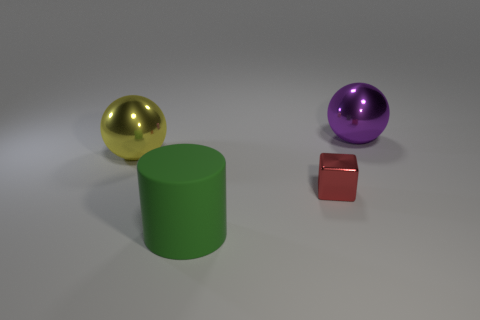Is there anything else that is the same material as the large green cylinder?
Your answer should be very brief. No. How many metallic things are both behind the shiny cube and right of the green cylinder?
Keep it short and to the point. 1. How many rubber things are yellow cylinders or big cylinders?
Keep it short and to the point. 1. The big thing behind the shiny sphere that is to the left of the large green matte thing is made of what material?
Ensure brevity in your answer.  Metal. There is a yellow object that is the same size as the purple thing; what is its shape?
Your response must be concise. Sphere. Is the number of large yellow objects less than the number of yellow matte balls?
Offer a very short reply. No. Are there any large shiny things that are left of the big metal object right of the metallic block?
Provide a short and direct response. Yes. What is the shape of the large purple object that is made of the same material as the yellow ball?
Make the answer very short. Sphere. Are there any other things of the same color as the big rubber thing?
Provide a short and direct response. No. How many other things are the same size as the yellow metallic thing?
Keep it short and to the point. 2. 